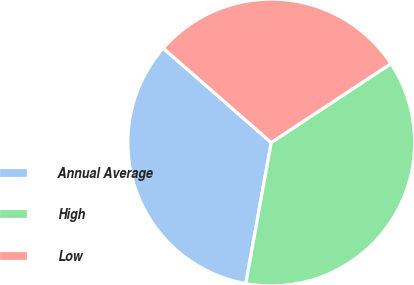<chart> <loc_0><loc_0><loc_500><loc_500><pie_chart><fcel>Annual Average<fcel>High<fcel>Low<nl><fcel>33.59%<fcel>37.11%<fcel>29.3%<nl></chart> 